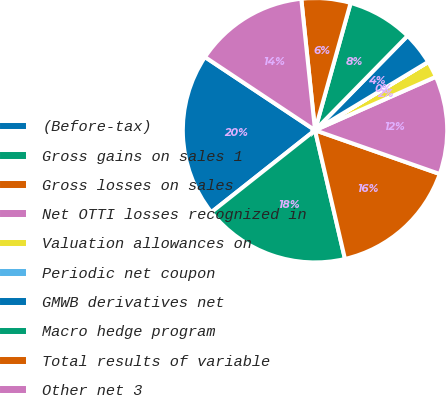Convert chart. <chart><loc_0><loc_0><loc_500><loc_500><pie_chart><fcel>(Before-tax)<fcel>Gross gains on sales 1<fcel>Gross losses on sales<fcel>Net OTTI losses recognized in<fcel>Valuation allowances on<fcel>Periodic net coupon<fcel>GMWB derivatives net<fcel>Macro hedge program<fcel>Total results of variable<fcel>Other net 3<nl><fcel>19.99%<fcel>17.99%<fcel>15.99%<fcel>12.0%<fcel>2.01%<fcel>0.01%<fcel>4.01%<fcel>8.0%<fcel>6.0%<fcel>14.0%<nl></chart> 